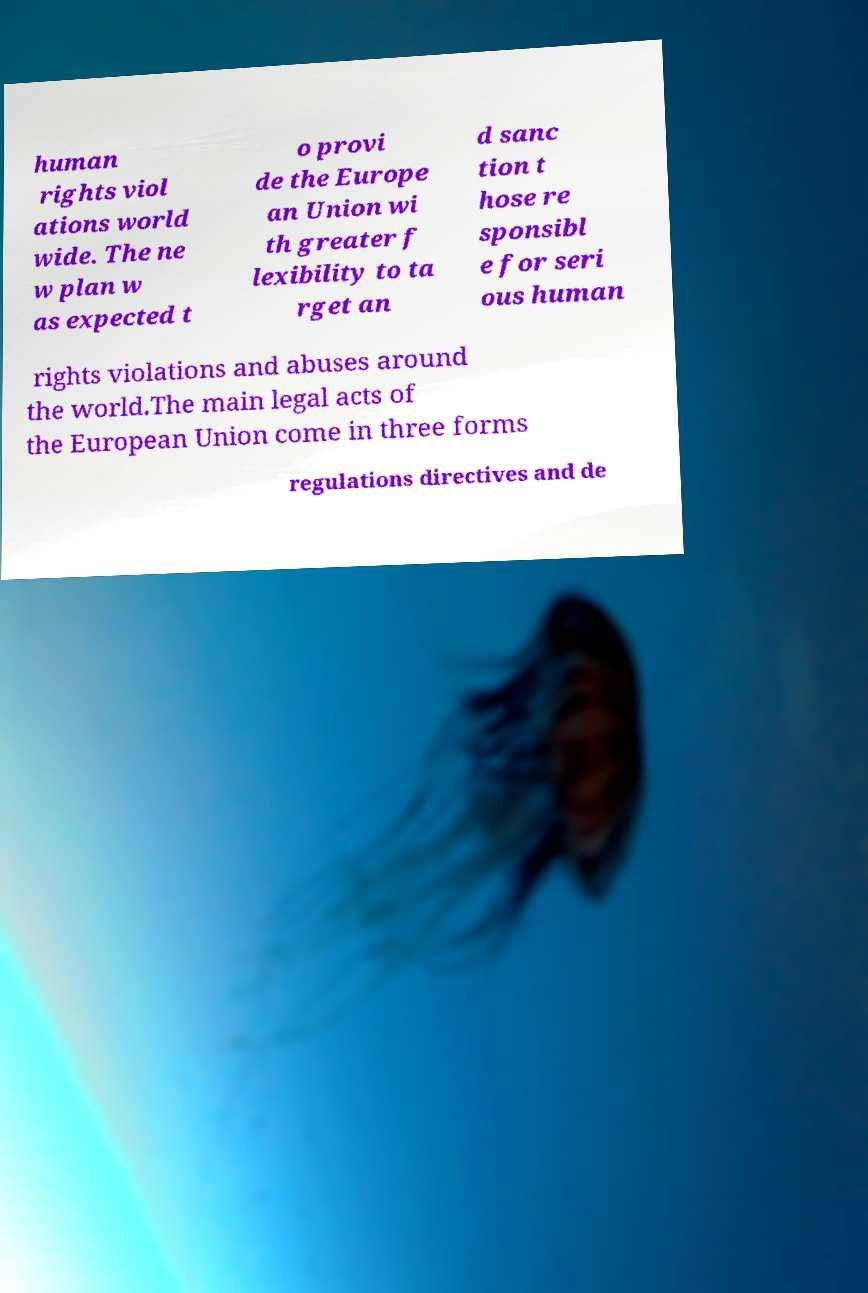For documentation purposes, I need the text within this image transcribed. Could you provide that? human rights viol ations world wide. The ne w plan w as expected t o provi de the Europe an Union wi th greater f lexibility to ta rget an d sanc tion t hose re sponsibl e for seri ous human rights violations and abuses around the world.The main legal acts of the European Union come in three forms regulations directives and de 